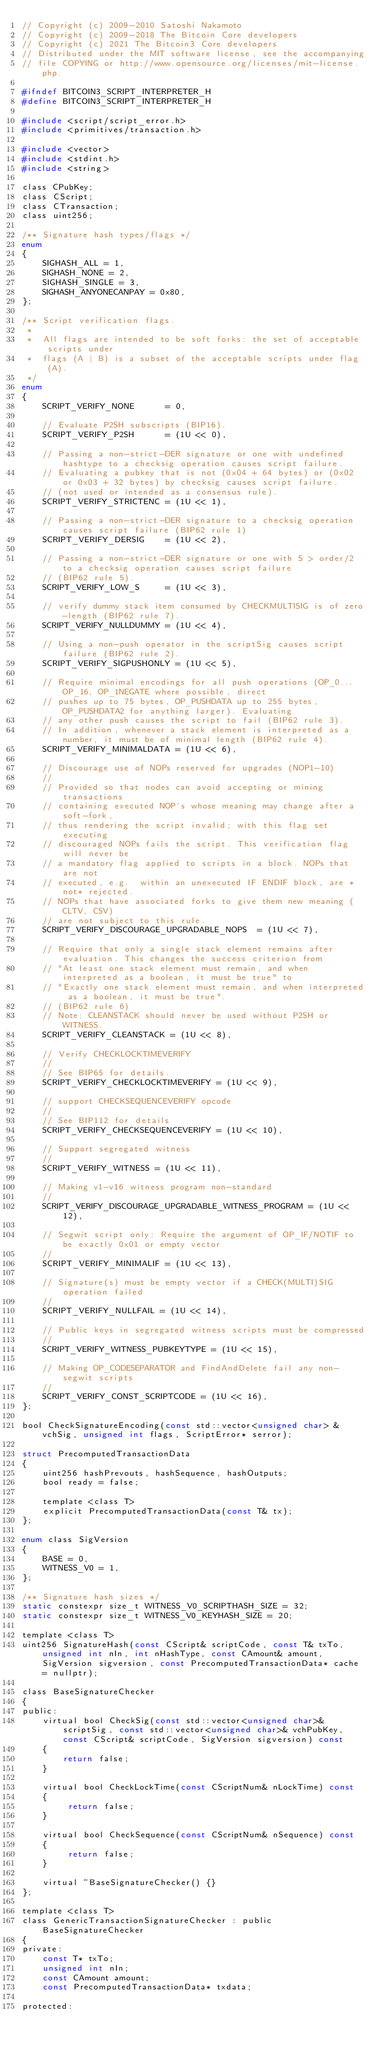Convert code to text. <code><loc_0><loc_0><loc_500><loc_500><_C_>// Copyright (c) 2009-2010 Satoshi Nakamoto
// Copyright (c) 2009-2018 The Bitcoin Core developers
// Copyright (c) 2021 The Bitcoin3 Core developers
// Distributed under the MIT software license, see the accompanying
// file COPYING or http://www.opensource.org/licenses/mit-license.php.

#ifndef BITCOIN3_SCRIPT_INTERPRETER_H
#define BITCOIN3_SCRIPT_INTERPRETER_H

#include <script/script_error.h>
#include <primitives/transaction.h>

#include <vector>
#include <stdint.h>
#include <string>

class CPubKey;
class CScript;
class CTransaction;
class uint256;

/** Signature hash types/flags */
enum
{
    SIGHASH_ALL = 1,
    SIGHASH_NONE = 2,
    SIGHASH_SINGLE = 3,
    SIGHASH_ANYONECANPAY = 0x80,
};

/** Script verification flags.
 *
 *  All flags are intended to be soft forks: the set of acceptable scripts under
 *  flags (A | B) is a subset of the acceptable scripts under flag (A).
 */
enum
{
    SCRIPT_VERIFY_NONE      = 0,

    // Evaluate P2SH subscripts (BIP16).
    SCRIPT_VERIFY_P2SH      = (1U << 0),

    // Passing a non-strict-DER signature or one with undefined hashtype to a checksig operation causes script failure.
    // Evaluating a pubkey that is not (0x04 + 64 bytes) or (0x02 or 0x03 + 32 bytes) by checksig causes script failure.
    // (not used or intended as a consensus rule).
    SCRIPT_VERIFY_STRICTENC = (1U << 1),

    // Passing a non-strict-DER signature to a checksig operation causes script failure (BIP62 rule 1)
    SCRIPT_VERIFY_DERSIG    = (1U << 2),

    // Passing a non-strict-DER signature or one with S > order/2 to a checksig operation causes script failure
    // (BIP62 rule 5).
    SCRIPT_VERIFY_LOW_S     = (1U << 3),

    // verify dummy stack item consumed by CHECKMULTISIG is of zero-length (BIP62 rule 7).
    SCRIPT_VERIFY_NULLDUMMY = (1U << 4),

    // Using a non-push operator in the scriptSig causes script failure (BIP62 rule 2).
    SCRIPT_VERIFY_SIGPUSHONLY = (1U << 5),

    // Require minimal encodings for all push operations (OP_0... OP_16, OP_1NEGATE where possible, direct
    // pushes up to 75 bytes, OP_PUSHDATA up to 255 bytes, OP_PUSHDATA2 for anything larger). Evaluating
    // any other push causes the script to fail (BIP62 rule 3).
    // In addition, whenever a stack element is interpreted as a number, it must be of minimal length (BIP62 rule 4).
    SCRIPT_VERIFY_MINIMALDATA = (1U << 6),

    // Discourage use of NOPs reserved for upgrades (NOP1-10)
    //
    // Provided so that nodes can avoid accepting or mining transactions
    // containing executed NOP's whose meaning may change after a soft-fork,
    // thus rendering the script invalid; with this flag set executing
    // discouraged NOPs fails the script. This verification flag will never be
    // a mandatory flag applied to scripts in a block. NOPs that are not
    // executed, e.g.  within an unexecuted IF ENDIF block, are *not* rejected.
    // NOPs that have associated forks to give them new meaning (CLTV, CSV)
    // are not subject to this rule.
    SCRIPT_VERIFY_DISCOURAGE_UPGRADABLE_NOPS  = (1U << 7),

    // Require that only a single stack element remains after evaluation. This changes the success criterion from
    // "At least one stack element must remain, and when interpreted as a boolean, it must be true" to
    // "Exactly one stack element must remain, and when interpreted as a boolean, it must be true".
    // (BIP62 rule 6)
    // Note: CLEANSTACK should never be used without P2SH or WITNESS.
    SCRIPT_VERIFY_CLEANSTACK = (1U << 8),

    // Verify CHECKLOCKTIMEVERIFY
    //
    // See BIP65 for details.
    SCRIPT_VERIFY_CHECKLOCKTIMEVERIFY = (1U << 9),

    // support CHECKSEQUENCEVERIFY opcode
    //
    // See BIP112 for details
    SCRIPT_VERIFY_CHECKSEQUENCEVERIFY = (1U << 10),

    // Support segregated witness
    //
    SCRIPT_VERIFY_WITNESS = (1U << 11),

    // Making v1-v16 witness program non-standard
    //
    SCRIPT_VERIFY_DISCOURAGE_UPGRADABLE_WITNESS_PROGRAM = (1U << 12),

    // Segwit script only: Require the argument of OP_IF/NOTIF to be exactly 0x01 or empty vector
    //
    SCRIPT_VERIFY_MINIMALIF = (1U << 13),

    // Signature(s) must be empty vector if a CHECK(MULTI)SIG operation failed
    //
    SCRIPT_VERIFY_NULLFAIL = (1U << 14),

    // Public keys in segregated witness scripts must be compressed
    //
    SCRIPT_VERIFY_WITNESS_PUBKEYTYPE = (1U << 15),

    // Making OP_CODESEPARATOR and FindAndDelete fail any non-segwit scripts
    //
    SCRIPT_VERIFY_CONST_SCRIPTCODE = (1U << 16),
};

bool CheckSignatureEncoding(const std::vector<unsigned char> &vchSig, unsigned int flags, ScriptError* serror);

struct PrecomputedTransactionData
{
    uint256 hashPrevouts, hashSequence, hashOutputs;
    bool ready = false;

    template <class T>
    explicit PrecomputedTransactionData(const T& tx);
};

enum class SigVersion
{
    BASE = 0,
    WITNESS_V0 = 1,
};

/** Signature hash sizes */
static constexpr size_t WITNESS_V0_SCRIPTHASH_SIZE = 32;
static constexpr size_t WITNESS_V0_KEYHASH_SIZE = 20;

template <class T>
uint256 SignatureHash(const CScript& scriptCode, const T& txTo, unsigned int nIn, int nHashType, const CAmount& amount, SigVersion sigversion, const PrecomputedTransactionData* cache = nullptr);

class BaseSignatureChecker
{
public:
    virtual bool CheckSig(const std::vector<unsigned char>& scriptSig, const std::vector<unsigned char>& vchPubKey, const CScript& scriptCode, SigVersion sigversion) const
    {
        return false;
    }

    virtual bool CheckLockTime(const CScriptNum& nLockTime) const
    {
         return false;
    }

    virtual bool CheckSequence(const CScriptNum& nSequence) const
    {
         return false;
    }

    virtual ~BaseSignatureChecker() {}
};

template <class T>
class GenericTransactionSignatureChecker : public BaseSignatureChecker
{
private:
    const T* txTo;
    unsigned int nIn;
    const CAmount amount;
    const PrecomputedTransactionData* txdata;

protected:</code> 